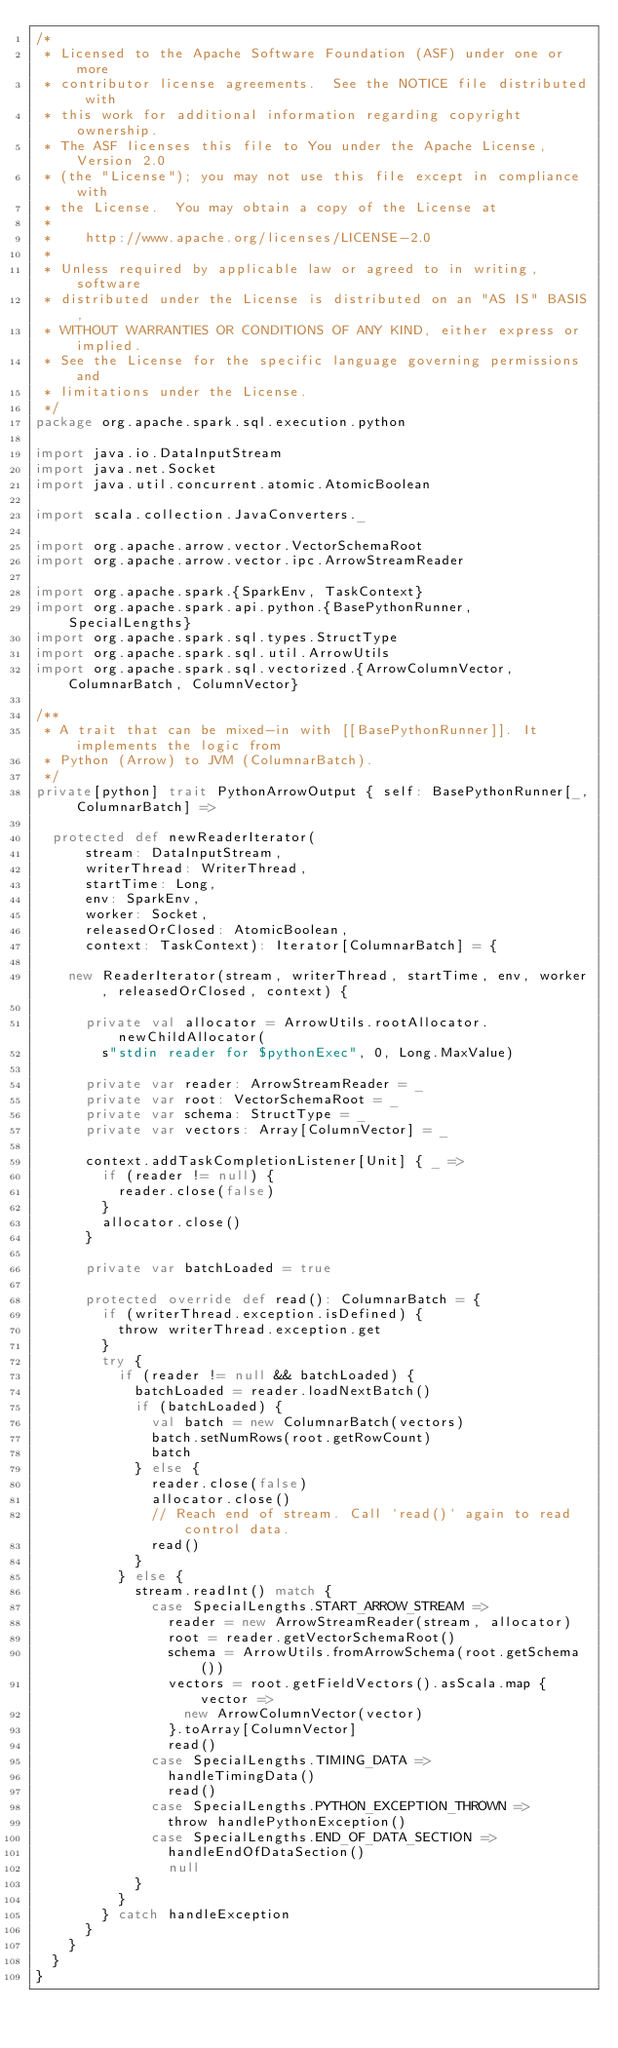Convert code to text. <code><loc_0><loc_0><loc_500><loc_500><_Scala_>/*
 * Licensed to the Apache Software Foundation (ASF) under one or more
 * contributor license agreements.  See the NOTICE file distributed with
 * this work for additional information regarding copyright ownership.
 * The ASF licenses this file to You under the Apache License, Version 2.0
 * (the "License"); you may not use this file except in compliance with
 * the License.  You may obtain a copy of the License at
 *
 *    http://www.apache.org/licenses/LICENSE-2.0
 *
 * Unless required by applicable law or agreed to in writing, software
 * distributed under the License is distributed on an "AS IS" BASIS,
 * WITHOUT WARRANTIES OR CONDITIONS OF ANY KIND, either express or implied.
 * See the License for the specific language governing permissions and
 * limitations under the License.
 */
package org.apache.spark.sql.execution.python

import java.io.DataInputStream
import java.net.Socket
import java.util.concurrent.atomic.AtomicBoolean

import scala.collection.JavaConverters._

import org.apache.arrow.vector.VectorSchemaRoot
import org.apache.arrow.vector.ipc.ArrowStreamReader

import org.apache.spark.{SparkEnv, TaskContext}
import org.apache.spark.api.python.{BasePythonRunner, SpecialLengths}
import org.apache.spark.sql.types.StructType
import org.apache.spark.sql.util.ArrowUtils
import org.apache.spark.sql.vectorized.{ArrowColumnVector, ColumnarBatch, ColumnVector}

/**
 * A trait that can be mixed-in with [[BasePythonRunner]]. It implements the logic from
 * Python (Arrow) to JVM (ColumnarBatch).
 */
private[python] trait PythonArrowOutput { self: BasePythonRunner[_, ColumnarBatch] =>

  protected def newReaderIterator(
      stream: DataInputStream,
      writerThread: WriterThread,
      startTime: Long,
      env: SparkEnv,
      worker: Socket,
      releasedOrClosed: AtomicBoolean,
      context: TaskContext): Iterator[ColumnarBatch] = {

    new ReaderIterator(stream, writerThread, startTime, env, worker, releasedOrClosed, context) {

      private val allocator = ArrowUtils.rootAllocator.newChildAllocator(
        s"stdin reader for $pythonExec", 0, Long.MaxValue)

      private var reader: ArrowStreamReader = _
      private var root: VectorSchemaRoot = _
      private var schema: StructType = _
      private var vectors: Array[ColumnVector] = _

      context.addTaskCompletionListener[Unit] { _ =>
        if (reader != null) {
          reader.close(false)
        }
        allocator.close()
      }

      private var batchLoaded = true

      protected override def read(): ColumnarBatch = {
        if (writerThread.exception.isDefined) {
          throw writerThread.exception.get
        }
        try {
          if (reader != null && batchLoaded) {
            batchLoaded = reader.loadNextBatch()
            if (batchLoaded) {
              val batch = new ColumnarBatch(vectors)
              batch.setNumRows(root.getRowCount)
              batch
            } else {
              reader.close(false)
              allocator.close()
              // Reach end of stream. Call `read()` again to read control data.
              read()
            }
          } else {
            stream.readInt() match {
              case SpecialLengths.START_ARROW_STREAM =>
                reader = new ArrowStreamReader(stream, allocator)
                root = reader.getVectorSchemaRoot()
                schema = ArrowUtils.fromArrowSchema(root.getSchema())
                vectors = root.getFieldVectors().asScala.map { vector =>
                  new ArrowColumnVector(vector)
                }.toArray[ColumnVector]
                read()
              case SpecialLengths.TIMING_DATA =>
                handleTimingData()
                read()
              case SpecialLengths.PYTHON_EXCEPTION_THROWN =>
                throw handlePythonException()
              case SpecialLengths.END_OF_DATA_SECTION =>
                handleEndOfDataSection()
                null
            }
          }
        } catch handleException
      }
    }
  }
}
</code> 